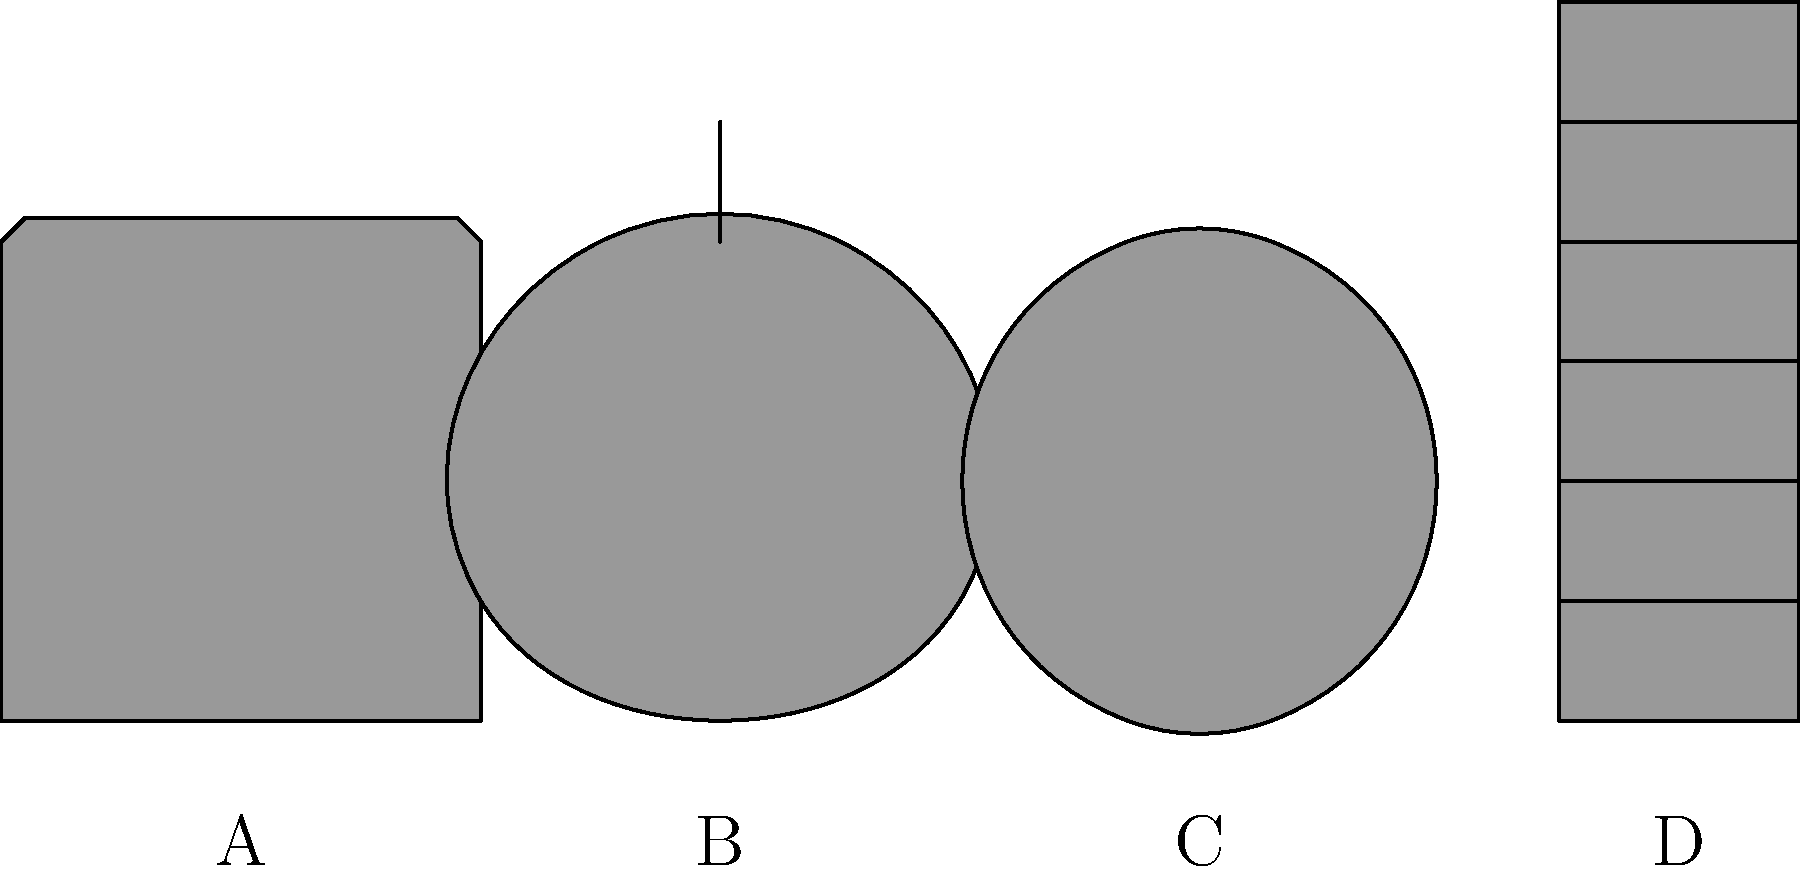As a lab director, you need to ensure that all lab personnel can correctly identify common lab apparatus. Match the sketches of lab equipment (A, B, C, D) with their correct scientific names:

1. Erlenmeyer Flask
2. Beaker
3. Graduated Cylinder
4. Test Tube To match the lab apparatus sketches with their correct scientific names, let's analyze each sketch:

1. Sketch A: This shows a cylindrical container with straight sides and a flat bottom. It has a wide mouth at the top, which is characteristic of a beaker. Beakers are used for mixing, stirring, and heating liquids.

2. Sketch B: This depicts a conical-shaped container with a flat bottom and a narrow neck. This is the distinctive shape of an Erlenmeyer flask, which is used for mixing, heating, and storing liquids. The narrow neck helps prevent spills and allows for easy swirling of contents.

3. Sketch C: This sketch shows a long, narrow, cylindrical tube that is closed at one end and open at the other. This is a test tube, commonly used for small-scale experiments, especially in chemistry and biology.

4. Sketch D: This illustration presents a tall, narrow cylindrical container with measurement markings along its length. This is a graduated cylinder, which is used for precise measurement of liquid volumes in laboratories.

Therefore, the correct matching is:
A - Beaker
B - Erlenmeyer Flask
C - Test Tube
D - Graduated Cylinder
Answer: A-2, B-1, C-4, D-3 